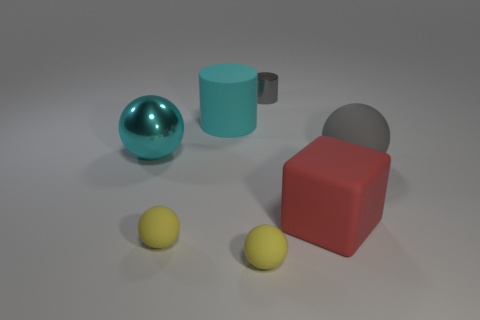Subtract all rubber spheres. How many spheres are left? 1 Subtract 2 balls. How many balls are left? 2 Subtract all cyan cylinders. How many cylinders are left? 1 Add 1 cyan things. How many objects exist? 8 Subtract all cylinders. How many objects are left? 5 Subtract all cyan spheres. How many blue cylinders are left? 0 Subtract all cyan objects. Subtract all tiny gray objects. How many objects are left? 4 Add 4 large red rubber blocks. How many large red rubber blocks are left? 5 Add 3 small objects. How many small objects exist? 6 Subtract 0 blue spheres. How many objects are left? 7 